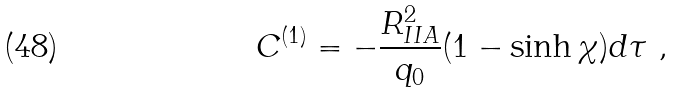<formula> <loc_0><loc_0><loc_500><loc_500>C ^ { ( 1 ) } = - \frac { R _ { I I A } ^ { 2 } } { q _ { 0 } } ( 1 - \sinh \chi ) d \tau \ ,</formula> 